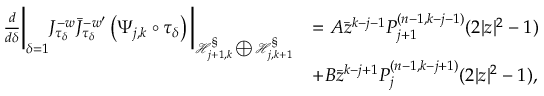<formula> <loc_0><loc_0><loc_500><loc_500>\begin{array} { r l } { \frac { d } { d \delta } \left | _ { \delta = 1 } J _ { \tau _ { \delta } } ^ { - w } \bar { J } _ { \tau _ { \delta } } ^ { - w ^ { \prime } } \left ( \Psi _ { j , k } \circ \tau _ { \delta } \right ) \right | _ { \mathcal { H } _ { j + 1 , k } ^ { \S } \bigoplus \mathcal { H } _ { j , k + 1 } ^ { \S } } } & { = A \bar { z } ^ { k - j - 1 } P _ { j + 1 } ^ { ( n - 1 , k - j - 1 ) } ( 2 | z | ^ { 2 } - 1 ) } \\ & { + B \bar { z } ^ { k - j + 1 } P _ { j } ^ { ( n - 1 , k - j + 1 ) } ( 2 | z | ^ { 2 } - 1 ) , } \end{array}</formula> 